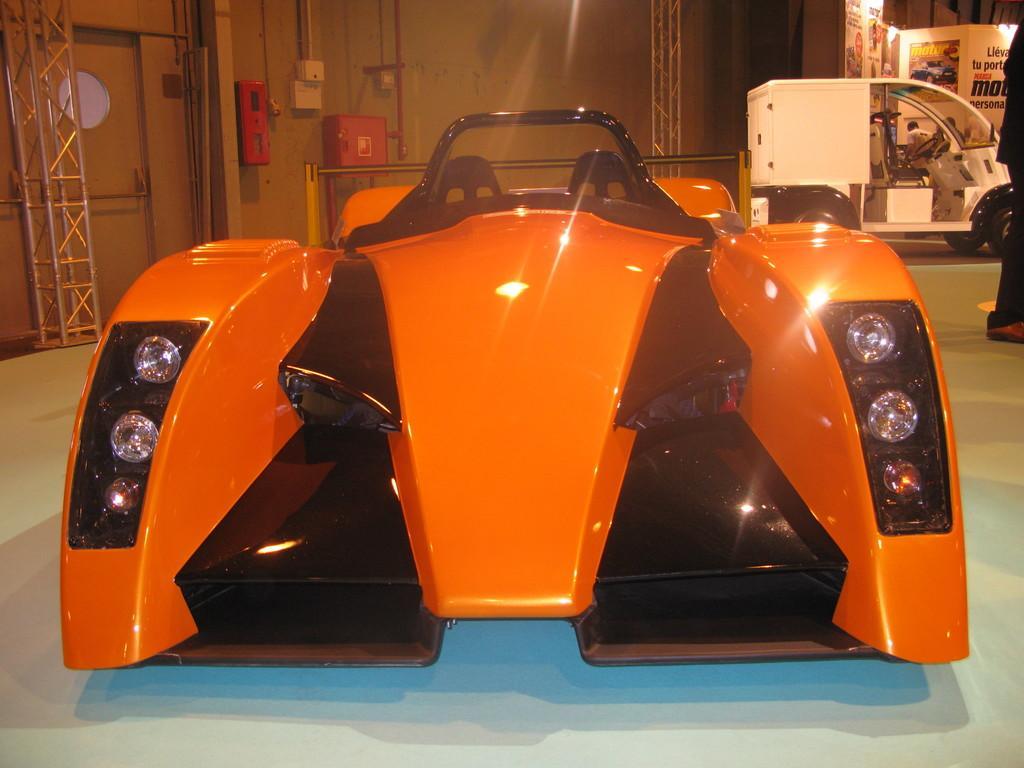Can you describe this image briefly? In this image we can see motor vehicles, iron grills, doors, pipelines, electric cabinets, advertisements and a person on the floor. 